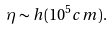Convert formula to latex. <formula><loc_0><loc_0><loc_500><loc_500>\eta \sim h ( 1 0 ^ { 5 } c m ) .</formula> 